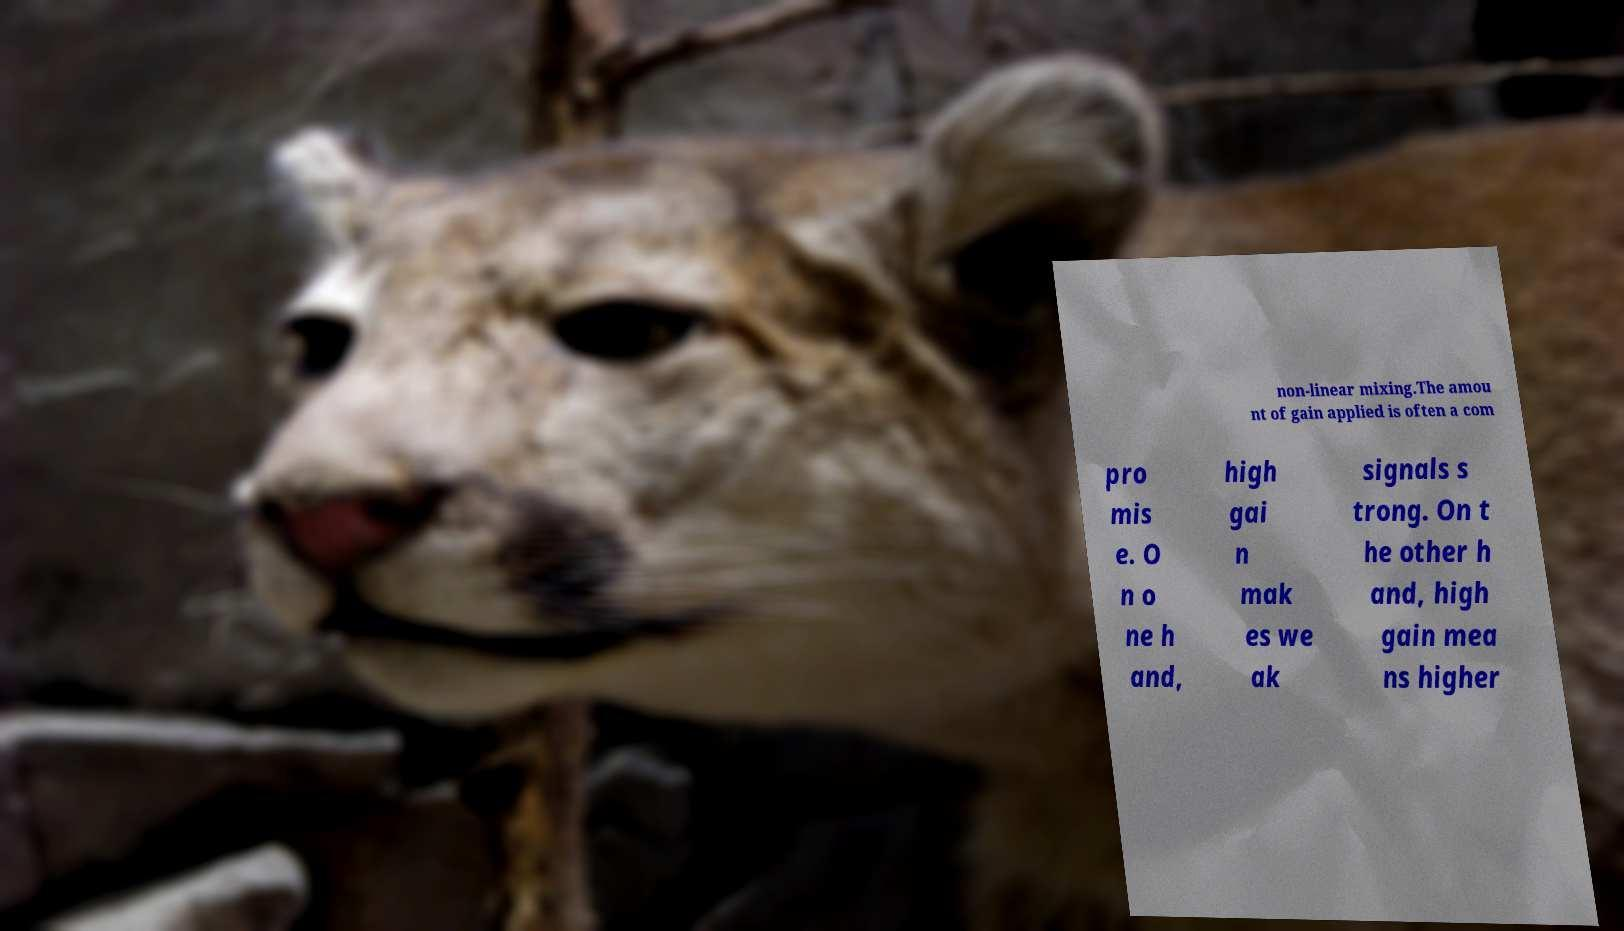Can you read and provide the text displayed in the image?This photo seems to have some interesting text. Can you extract and type it out for me? non-linear mixing.The amou nt of gain applied is often a com pro mis e. O n o ne h and, high gai n mak es we ak signals s trong. On t he other h and, high gain mea ns higher 